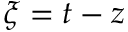Convert formula to latex. <formula><loc_0><loc_0><loc_500><loc_500>\xi = t - z</formula> 